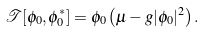Convert formula to latex. <formula><loc_0><loc_0><loc_500><loc_500>\mathcal { T } [ \phi _ { 0 } , \phi ^ { \ast } _ { 0 } ] = \phi _ { 0 } \left ( \mu - g | \phi _ { 0 } | ^ { 2 } \right ) .</formula> 